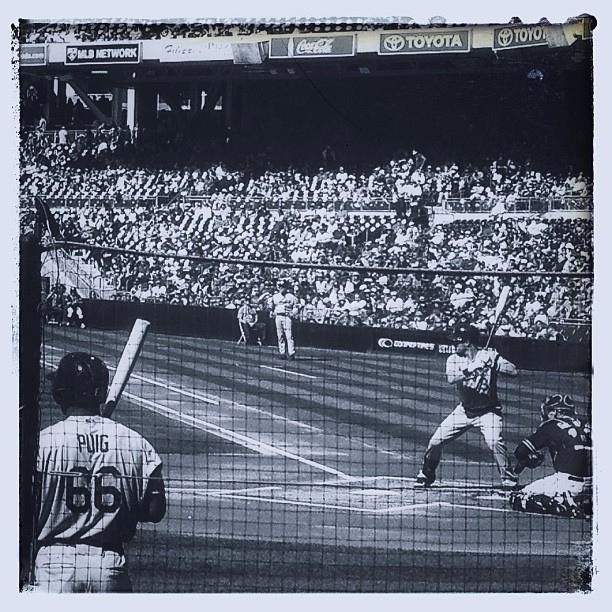What car company is being advertised?
Write a very short answer. Toyota. Who will be batting next?
Short answer required. 66. What sports are they playing?
Keep it brief. Baseball. 